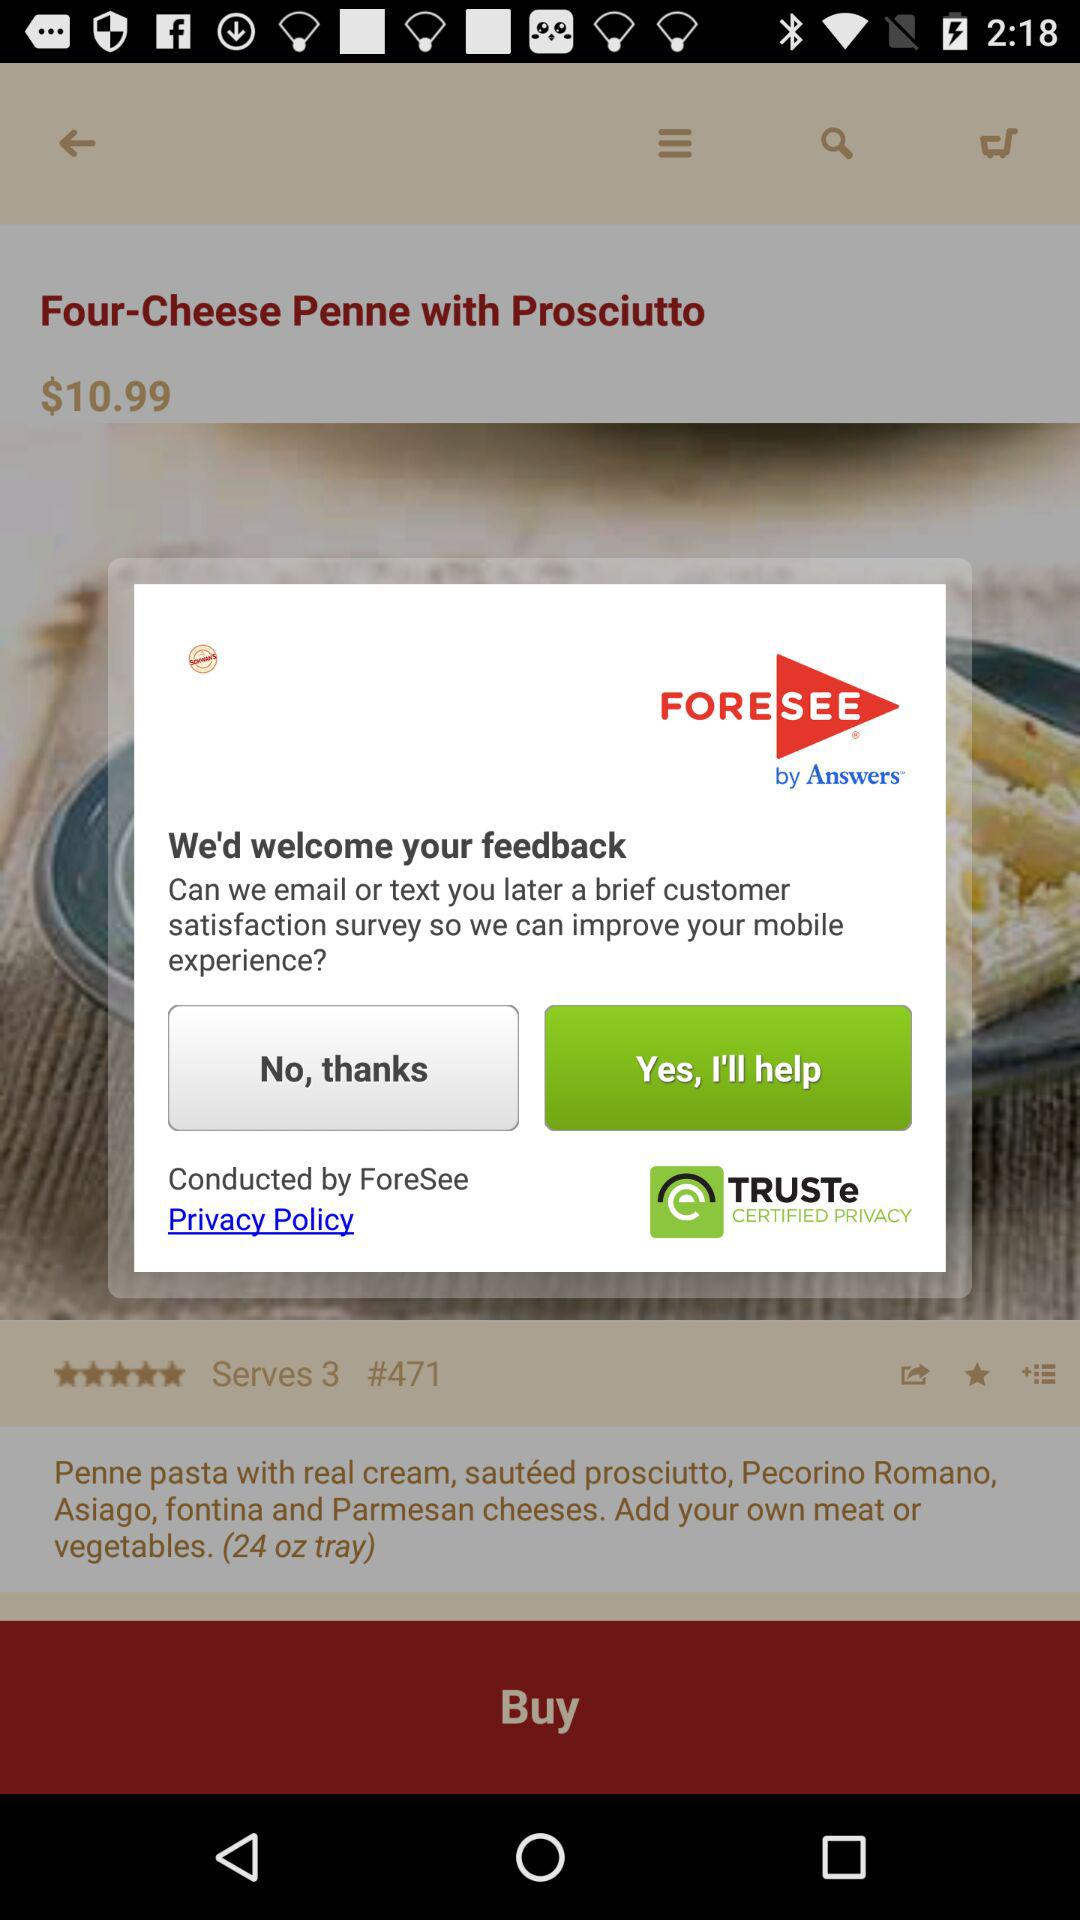What is the price of the Four-Cheese Penne with Prosciutto? The price of the Four-Cheese Penne with Prosciutto is $10.99. 